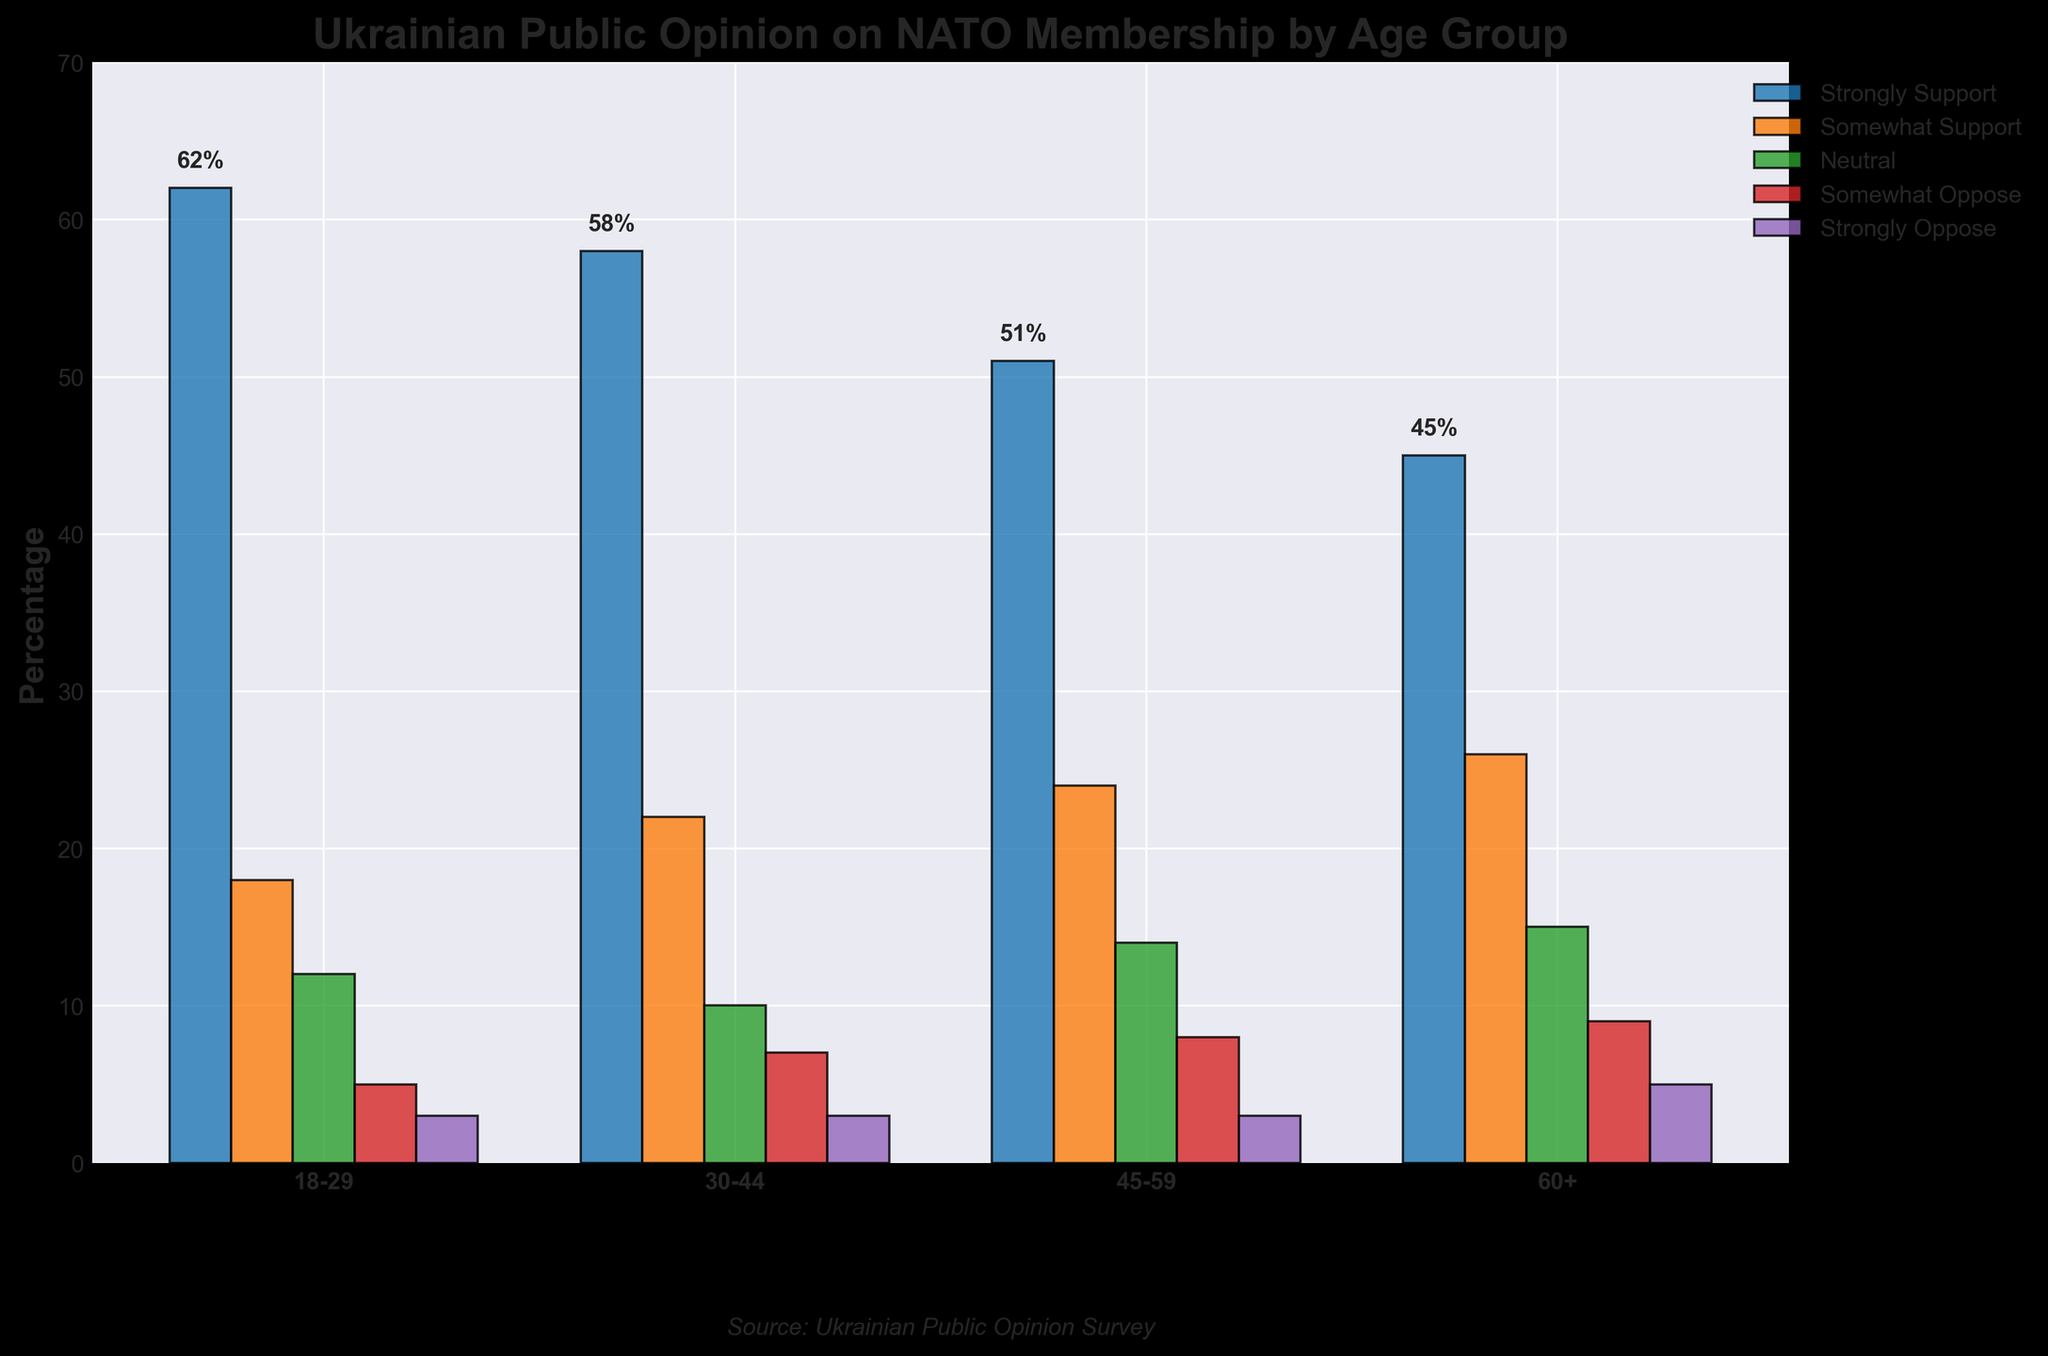Which age group has the highest percentage of strong support for NATO membership? The bar for "Strongly Support" is the highest for the age group 18-29.
Answer: 18-29 Which age group has the lowest percentage of strong opposition to NATO membership? The bar for "Strongly Oppose" is the lowest for the age group 18-29.
Answer: 18-29 What is the sum of somewhat support percentages for all age groups? Add the percentages for "Somewhat Support" across all age groups: 18+22+24+26 = 90%.
Answer: 90% Is the percentage of neutral opinion higher for the age group 45-59 or 60+? The bar for "Neutral" looks longer for the age group 60+ compared to 45-59.
Answer: 60+ How much more is the percentage of strong support for NATO membership in the 18-29 age group compared to the 60+ age group? Subtract the percentage of 60+ from 18-29 for "Strongly Support": 62% - 45% = 17%.
Answer: 17% Which support level shows the least variation among age groups? The bars for "Strongly Oppose" appear to be quite consistent across all age groups.
Answer: Strongly Oppose Compare the total percentage (sum of all levels) for both support and opposition across age groups. Which ideology, support or opposition, is more popular among Ukrainians? Support levels (Strongly Support + Somewhat Support): 62+18 + 58+22 + 51+24 + 45+26 = 306%. Opposition levels (Somewhat Oppose + Strongly Oppose): 5+3 + 7+3 + 8+3 + 9+5 = 43%. Thus, support is significantly more popular.
Answer: Support What is the difference between the highest and lowest percentage values for "Strongly Support" across age groups? The highest percentage for "Strongly Support" is 62% (18-29), and the lowest is 45% (60+). The difference is 62% - 45% = 17%.
Answer: 17% How does the percentage of "Somewhat Oppose" change from the youngest age group to the oldest? The percentage of "Somewhat Oppose" increases from 5% (18-29) to 9% (60+).
Answer: It increases by 4% 